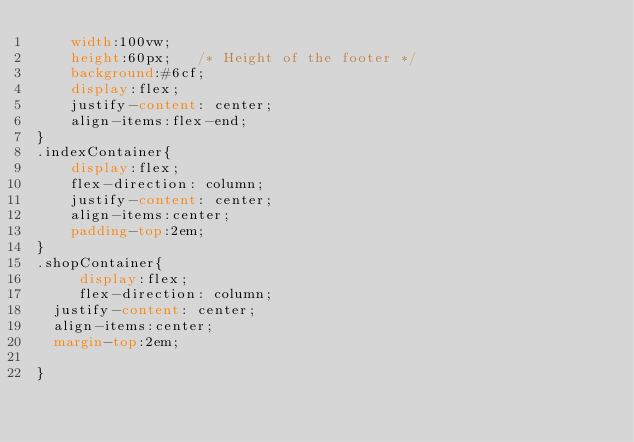Convert code to text. <code><loc_0><loc_0><loc_500><loc_500><_CSS_>    width:100vw;
    height:60px;   /* Height of the footer */
    background:#6cf;
    display:flex;
    justify-content: center;
    align-items:flex-end;
}
.indexContainer{
    display:flex;
    flex-direction: column;
    justify-content: center;
    align-items:center;
    padding-top:2em;
}
.shopContainer{
     display:flex;
     flex-direction: column;
  justify-content: center;
  align-items:center;
  margin-top:2em;

}
</code> 